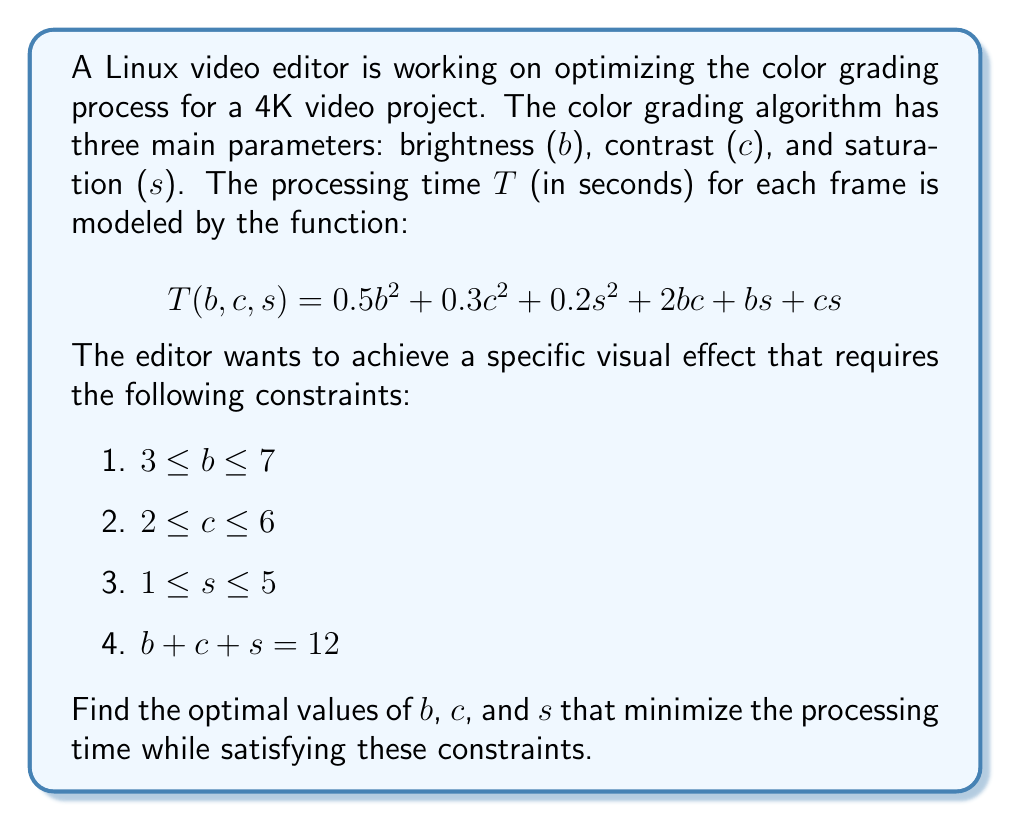What is the answer to this math problem? To solve this optimization problem, we'll use the method of Lagrange multipliers with inequality constraints (Karush-Kuhn-Tucker conditions). Here's a step-by-step approach:

1) First, we form the Lagrangian function:
   $$L(b,c,s,\lambda) = 0.5b^2 + 0.3c^2 + 0.2s^2 + 2bc + bs + cs + \lambda(b + c + s - 12)$$

2) We then take partial derivatives and set them to zero:
   $$\frac{\partial L}{\partial b} = b + 2c + s + \lambda = 0$$
   $$\frac{\partial L}{\partial c} = 0.6c + 2b + s + \lambda = 0$$
   $$\frac{\partial L}{\partial s} = 0.4s + b + c + \lambda = 0$$
   $$\frac{\partial L}{\partial \lambda} = b + c + s - 12 = 0$$

3) From these equations, we can derive:
   $$0.4b - 0.6c = 0$$
   $$0.6b - 0.4s = 0$$

4) Solving these along with $b + c + s = 12$, we get:
   $$b = 5, c = \frac{10}{3}, s = \frac{16}{3}$$

5) However, we need to check if this solution satisfies our inequality constraints:
   $3 \leq 5 \leq 7$ (satisfied)
   $2 \leq \frac{10}{3} \leq 6$ (satisfied)
   $1 \leq \frac{16}{3} \leq 5$ (not satisfied, as $\frac{16}{3} \approx 5.33 > 5$)

6) Since the unconstrained optimum violates a constraint, the true optimum must lie on the boundary of the feasible region. Specifically, it will be when $s = 5$.

7) Using $b + c + s = 12$ and $s = 5$, we have $b + c = 7$.

8) Substituting these into our objective function:
   $$T(b,7-b,5) = 0.5b^2 + 0.3(7-b)^2 + 0.2(5)^2 + 2b(7-b) + 5b + 5(7-b)$$

9) Simplifying and differentiating with respect to $b$:
   $$\frac{dT}{db} = 0.8b - 2.1 = 0$$

10) Solving this, we get $b = \frac{21}{8} = 2.625$. However, this violates our constraint $3 \leq b \leq 7$.

11) Therefore, the optimum must occur at $b = 3$ (the nearest feasible point), which gives $c = 4$.

12) Thus, the optimal solution is $b = 3$, $c = 4$, and $s = 5$.
Answer: $b = 3$, $c = 4$, $s = 5$ 